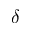<formula> <loc_0><loc_0><loc_500><loc_500>\delta</formula> 